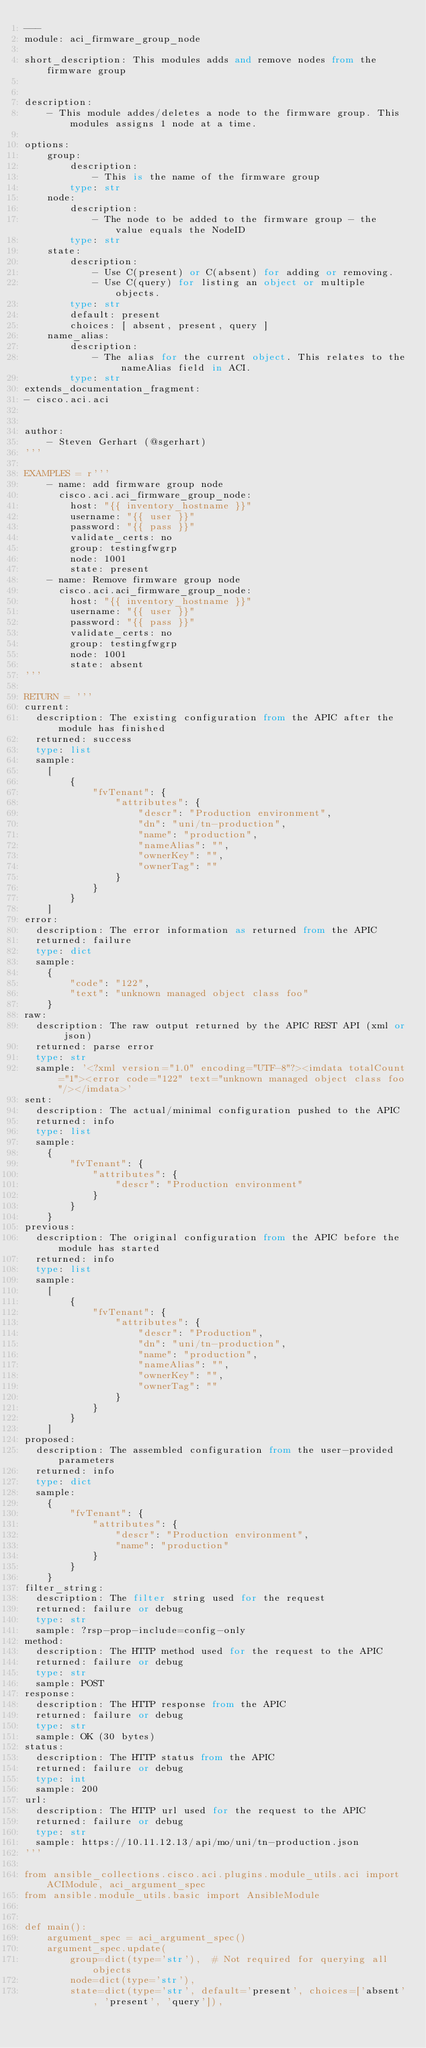Convert code to text. <code><loc_0><loc_0><loc_500><loc_500><_Python_>---
module: aci_firmware_group_node

short_description: This modules adds and remove nodes from the firmware group


description:
    - This module addes/deletes a node to the firmware group. This modules assigns 1 node at a time.

options:
    group:
        description:
            - This is the name of the firmware group
        type: str
    node:
        description:
            - The node to be added to the firmware group - the value equals the NodeID
        type: str
    state:
        description:
            - Use C(present) or C(absent) for adding or removing.
            - Use C(query) for listing an object or multiple objects.
        type: str
        default: present
        choices: [ absent, present, query ]
    name_alias:
        description:
            - The alias for the current object. This relates to the nameAlias field in ACI.
        type: str
extends_documentation_fragment:
- cisco.aci.aci


author:
    - Steven Gerhart (@sgerhart)
'''

EXAMPLES = r'''
    - name: add firmware group node
      cisco.aci.aci_firmware_group_node:
        host: "{{ inventory_hostname }}"
        username: "{{ user }}"
        password: "{{ pass }}"
        validate_certs: no
        group: testingfwgrp
        node: 1001
        state: present
    - name: Remove firmware group node
      cisco.aci.aci_firmware_group_node:
        host: "{{ inventory_hostname }}"
        username: "{{ user }}"
        password: "{{ pass }}"
        validate_certs: no
        group: testingfwgrp
        node: 1001
        state: absent
'''

RETURN = '''
current:
  description: The existing configuration from the APIC after the module has finished
  returned: success
  type: list
  sample:
    [
        {
            "fvTenant": {
                "attributes": {
                    "descr": "Production environment",
                    "dn": "uni/tn-production",
                    "name": "production",
                    "nameAlias": "",
                    "ownerKey": "",
                    "ownerTag": ""
                }
            }
        }
    ]
error:
  description: The error information as returned from the APIC
  returned: failure
  type: dict
  sample:
    {
        "code": "122",
        "text": "unknown managed object class foo"
    }
raw:
  description: The raw output returned by the APIC REST API (xml or json)
  returned: parse error
  type: str
  sample: '<?xml version="1.0" encoding="UTF-8"?><imdata totalCount="1"><error code="122" text="unknown managed object class foo"/></imdata>'
sent:
  description: The actual/minimal configuration pushed to the APIC
  returned: info
  type: list
  sample:
    {
        "fvTenant": {
            "attributes": {
                "descr": "Production environment"
            }
        }
    }
previous:
  description: The original configuration from the APIC before the module has started
  returned: info
  type: list
  sample:
    [
        {
            "fvTenant": {
                "attributes": {
                    "descr": "Production",
                    "dn": "uni/tn-production",
                    "name": "production",
                    "nameAlias": "",
                    "ownerKey": "",
                    "ownerTag": ""
                }
            }
        }
    ]
proposed:
  description: The assembled configuration from the user-provided parameters
  returned: info
  type: dict
  sample:
    {
        "fvTenant": {
            "attributes": {
                "descr": "Production environment",
                "name": "production"
            }
        }
    }
filter_string:
  description: The filter string used for the request
  returned: failure or debug
  type: str
  sample: ?rsp-prop-include=config-only
method:
  description: The HTTP method used for the request to the APIC
  returned: failure or debug
  type: str
  sample: POST
response:
  description: The HTTP response from the APIC
  returned: failure or debug
  type: str
  sample: OK (30 bytes)
status:
  description: The HTTP status from the APIC
  returned: failure or debug
  type: int
  sample: 200
url:
  description: The HTTP url used for the request to the APIC
  returned: failure or debug
  type: str
  sample: https://10.11.12.13/api/mo/uni/tn-production.json
'''

from ansible_collections.cisco.aci.plugins.module_utils.aci import ACIModule, aci_argument_spec
from ansible.module_utils.basic import AnsibleModule


def main():
    argument_spec = aci_argument_spec()
    argument_spec.update(
        group=dict(type='str'),  # Not required for querying all objects
        node=dict(type='str'),
        state=dict(type='str', default='present', choices=['absent', 'present', 'query']),</code> 